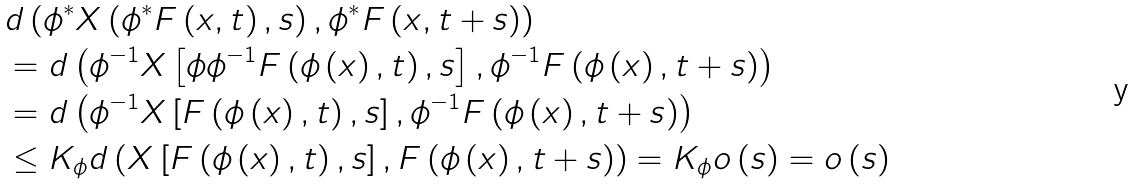<formula> <loc_0><loc_0><loc_500><loc_500>& d \left ( \phi ^ { \ast } X \left ( \phi ^ { \ast } F \left ( x , t \right ) , s \right ) , \phi ^ { \ast } F \left ( x , t + s \right ) \right ) \\ & = d \left ( \phi ^ { - 1 } X \left [ \phi \phi ^ { - 1 } F \left ( \phi \left ( x \right ) , t \right ) , s \right ] , \phi ^ { - 1 } F \left ( \phi \left ( x \right ) , t + s \right ) \right ) \\ & = d \left ( \phi ^ { - 1 } X \left [ F \left ( \phi \left ( x \right ) , t \right ) , s \right ] , \phi ^ { - 1 } F \left ( \phi \left ( x \right ) , t + s \right ) \right ) \\ & \leq K _ { \phi } d \left ( X \left [ F \left ( \phi \left ( x \right ) , t \right ) , s \right ] , F \left ( \phi \left ( x \right ) , t + s \right ) \right ) = K _ { \phi } o \left ( s \right ) = o \left ( s \right )</formula> 